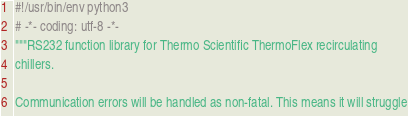<code> <loc_0><loc_0><loc_500><loc_500><_Python_>#!/usr/bin/env python3
# -*- coding: utf-8 -*-
"""RS232 function library for Thermo Scientific ThermoFlex recirculating
chillers.

Communication errors will be handled as non-fatal. This means it will struggle</code> 